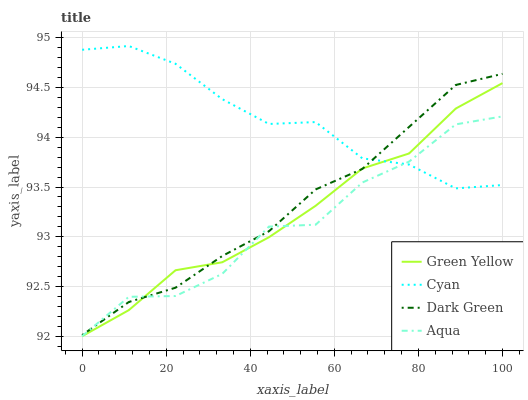Does Aqua have the minimum area under the curve?
Answer yes or no. Yes. Does Cyan have the maximum area under the curve?
Answer yes or no. Yes. Does Green Yellow have the minimum area under the curve?
Answer yes or no. No. Does Green Yellow have the maximum area under the curve?
Answer yes or no. No. Is Dark Green the smoothest?
Answer yes or no. Yes. Is Aqua the roughest?
Answer yes or no. Yes. Is Green Yellow the smoothest?
Answer yes or no. No. Is Green Yellow the roughest?
Answer yes or no. No. Does Green Yellow have the lowest value?
Answer yes or no. Yes. Does Dark Green have the lowest value?
Answer yes or no. No. Does Cyan have the highest value?
Answer yes or no. Yes. Does Green Yellow have the highest value?
Answer yes or no. No. Does Aqua intersect Dark Green?
Answer yes or no. Yes. Is Aqua less than Dark Green?
Answer yes or no. No. Is Aqua greater than Dark Green?
Answer yes or no. No. 